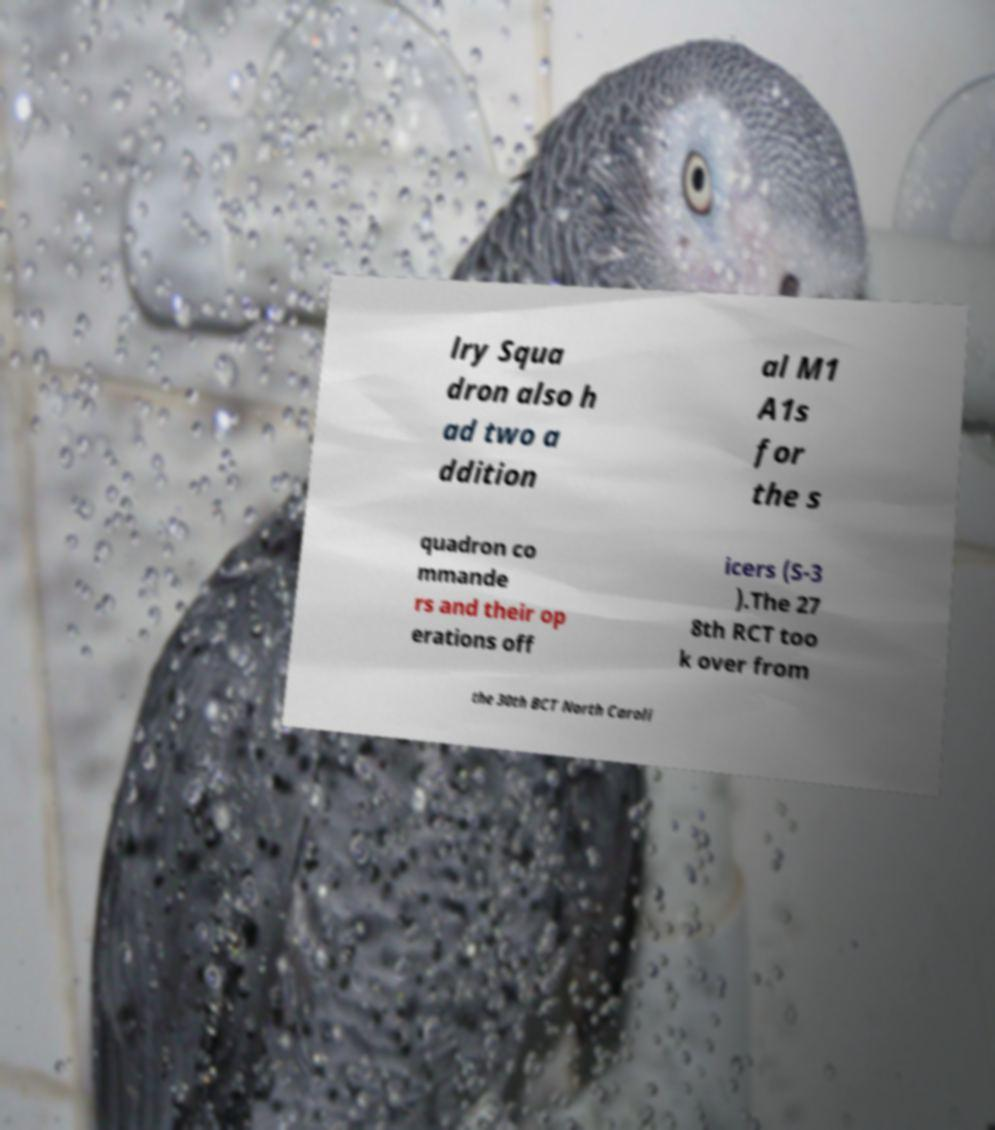Could you assist in decoding the text presented in this image and type it out clearly? lry Squa dron also h ad two a ddition al M1 A1s for the s quadron co mmande rs and their op erations off icers (S-3 ).The 27 8th RCT too k over from the 30th BCT North Caroli 